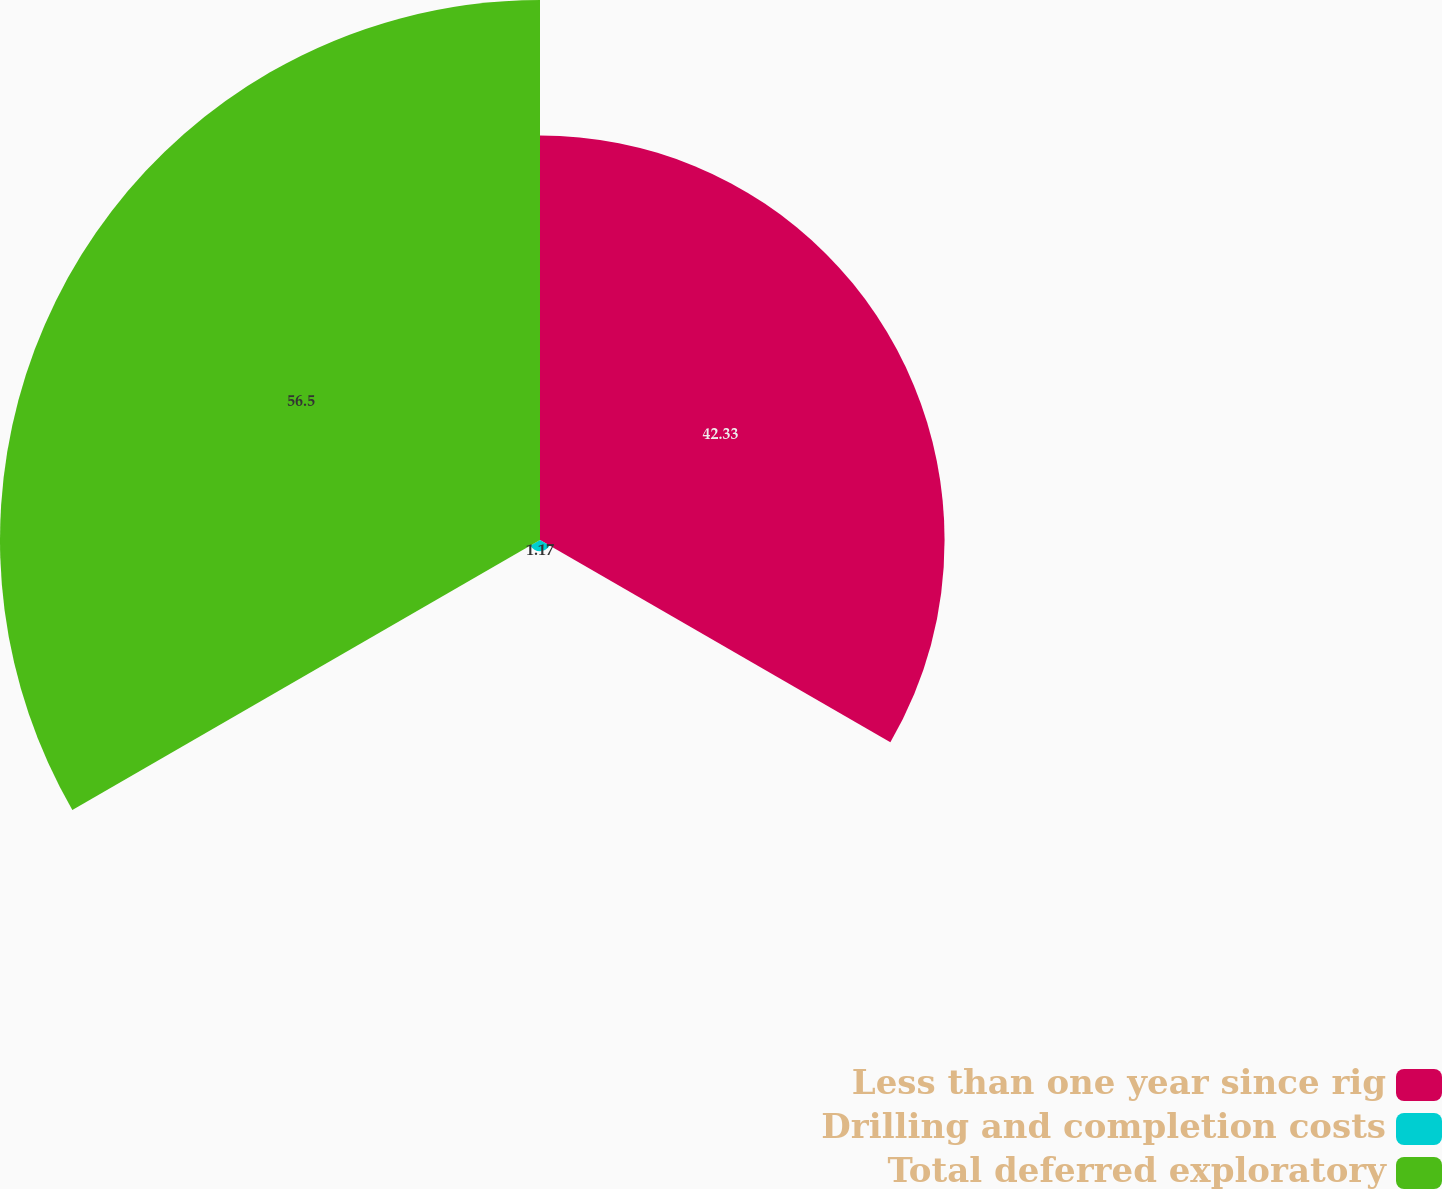Convert chart. <chart><loc_0><loc_0><loc_500><loc_500><pie_chart><fcel>Less than one year since rig<fcel>Drilling and completion costs<fcel>Total deferred exploratory<nl><fcel>42.33%<fcel>1.17%<fcel>56.5%<nl></chart> 